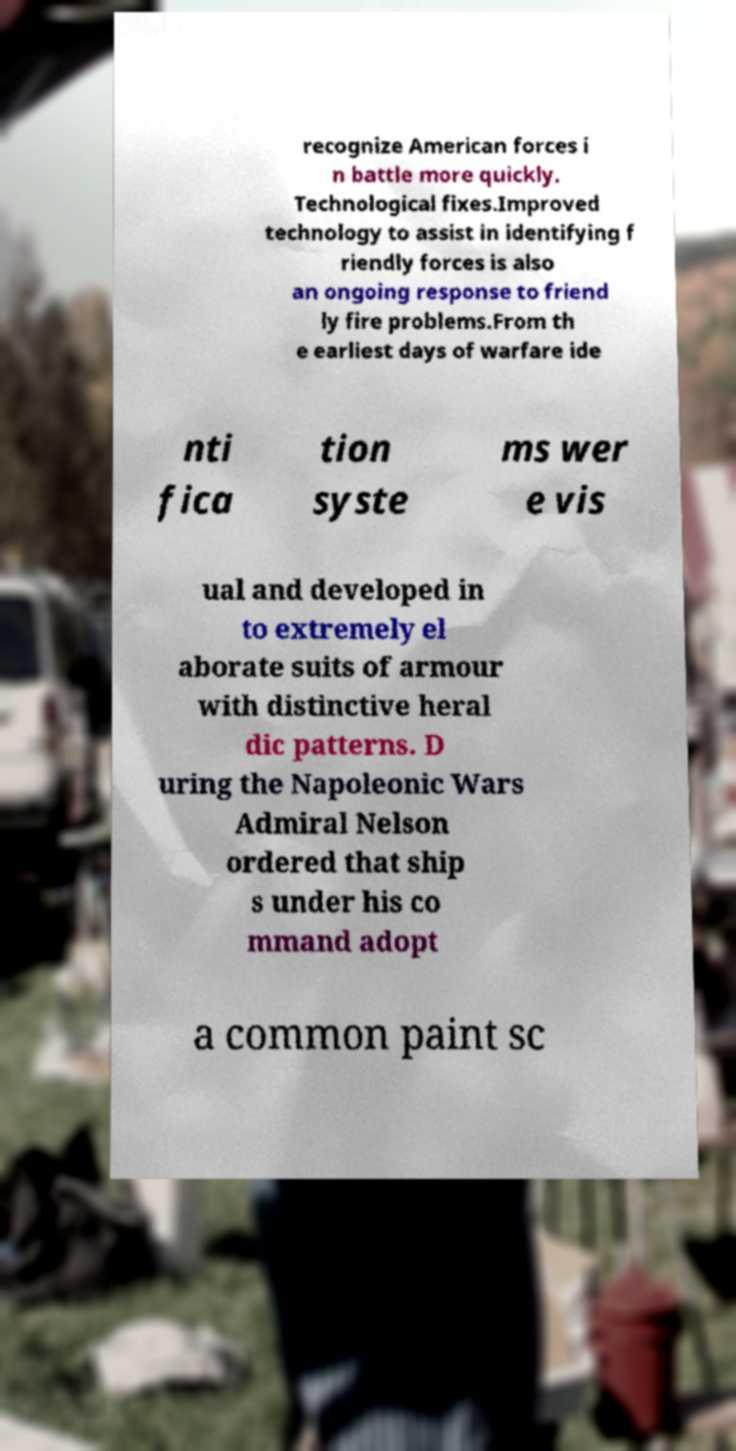I need the written content from this picture converted into text. Can you do that? recognize American forces i n battle more quickly. Technological fixes.Improved technology to assist in identifying f riendly forces is also an ongoing response to friend ly fire problems.From th e earliest days of warfare ide nti fica tion syste ms wer e vis ual and developed in to extremely el aborate suits of armour with distinctive heral dic patterns. D uring the Napoleonic Wars Admiral Nelson ordered that ship s under his co mmand adopt a common paint sc 